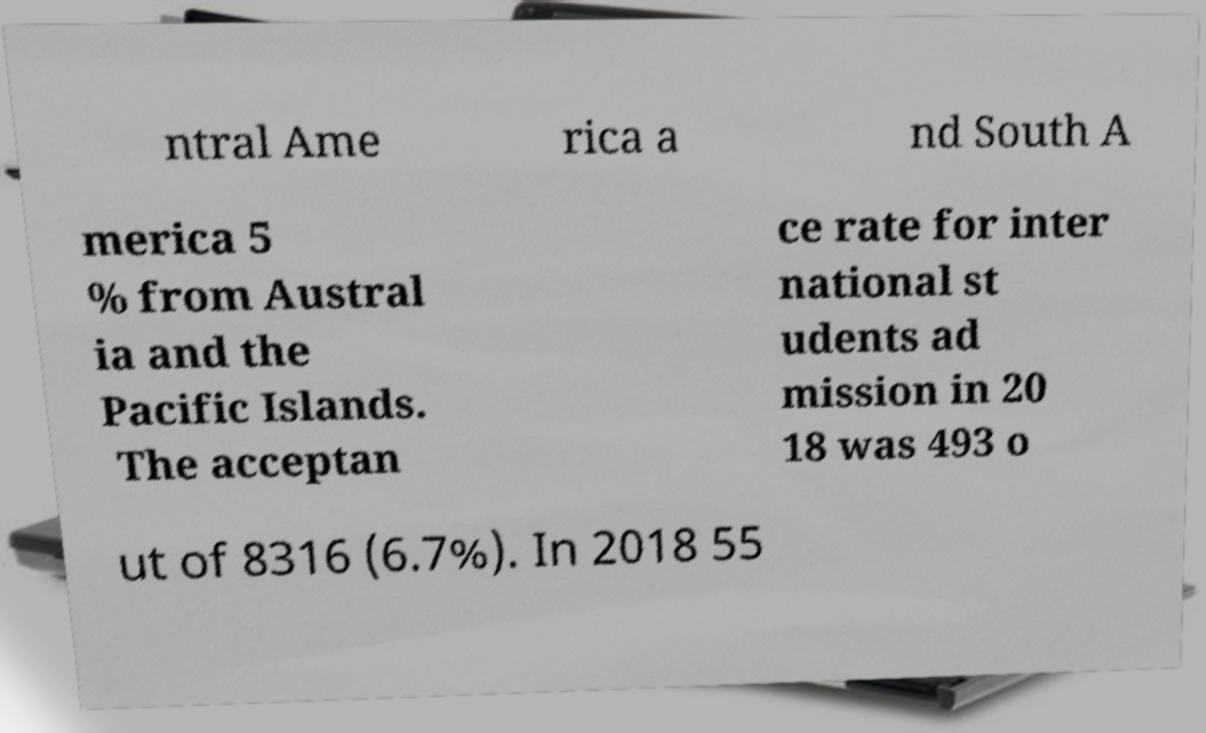Can you accurately transcribe the text from the provided image for me? ntral Ame rica a nd South A merica 5 % from Austral ia and the Pacific Islands. The acceptan ce rate for inter national st udents ad mission in 20 18 was 493 o ut of 8316 (6.7%). In 2018 55 